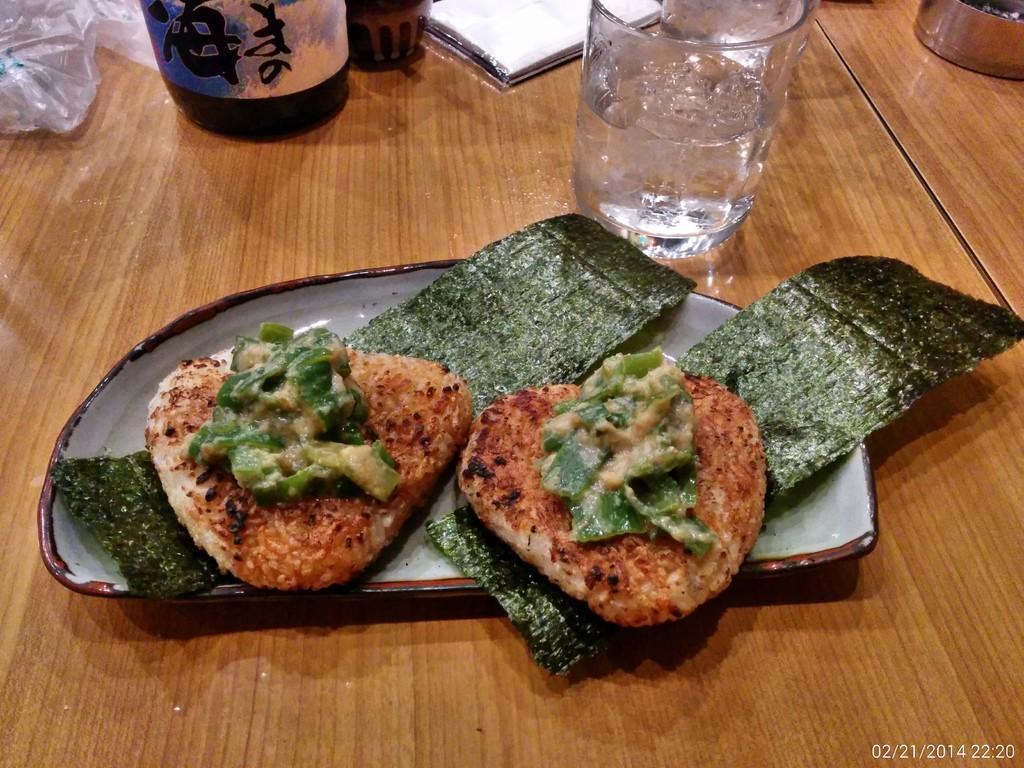In one or two sentences, can you explain what this image depicts? Here in this picture we can see some food items present on a plate, which is present on the table over there and we can also see a bottle and a glass present and we can see a cover and a book also present over there. 